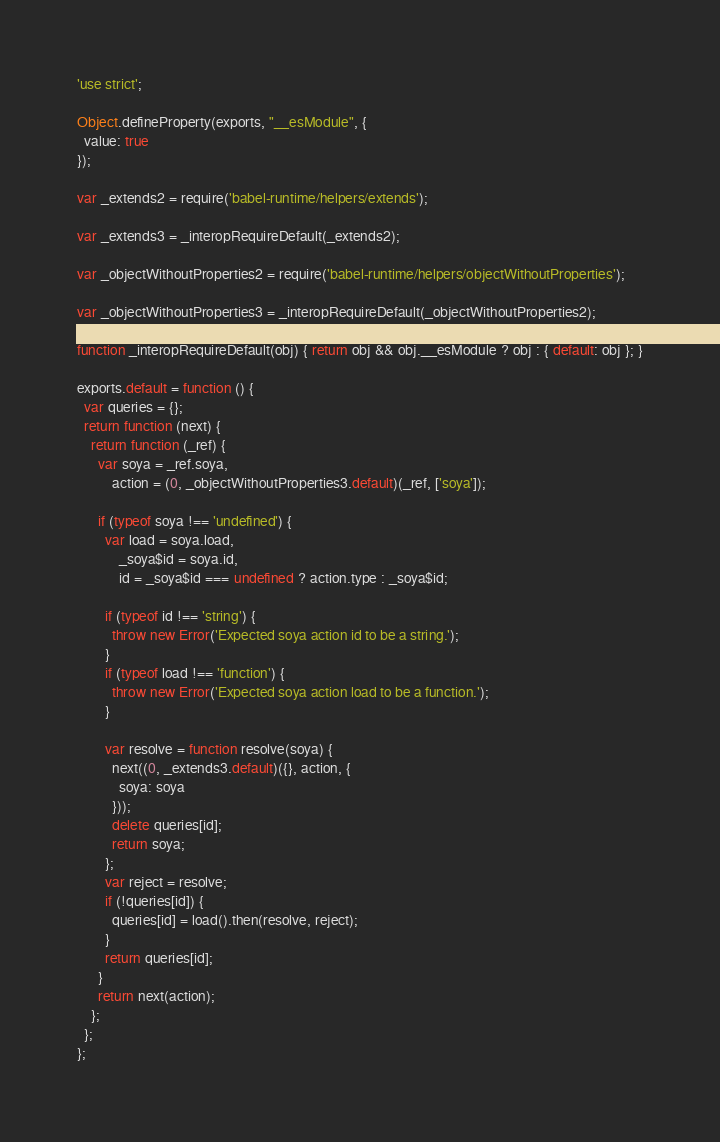Convert code to text. <code><loc_0><loc_0><loc_500><loc_500><_JavaScript_>'use strict';

Object.defineProperty(exports, "__esModule", {
  value: true
});

var _extends2 = require('babel-runtime/helpers/extends');

var _extends3 = _interopRequireDefault(_extends2);

var _objectWithoutProperties2 = require('babel-runtime/helpers/objectWithoutProperties');

var _objectWithoutProperties3 = _interopRequireDefault(_objectWithoutProperties2);

function _interopRequireDefault(obj) { return obj && obj.__esModule ? obj : { default: obj }; }

exports.default = function () {
  var queries = {};
  return function (next) {
    return function (_ref) {
      var soya = _ref.soya,
          action = (0, _objectWithoutProperties3.default)(_ref, ['soya']);

      if (typeof soya !== 'undefined') {
        var load = soya.load,
            _soya$id = soya.id,
            id = _soya$id === undefined ? action.type : _soya$id;

        if (typeof id !== 'string') {
          throw new Error('Expected soya action id to be a string.');
        }
        if (typeof load !== 'function') {
          throw new Error('Expected soya action load to be a function.');
        }

        var resolve = function resolve(soya) {
          next((0, _extends3.default)({}, action, {
            soya: soya
          }));
          delete queries[id];
          return soya;
        };
        var reject = resolve;
        if (!queries[id]) {
          queries[id] = load().then(resolve, reject);
        }
        return queries[id];
      }
      return next(action);
    };
  };
};</code> 